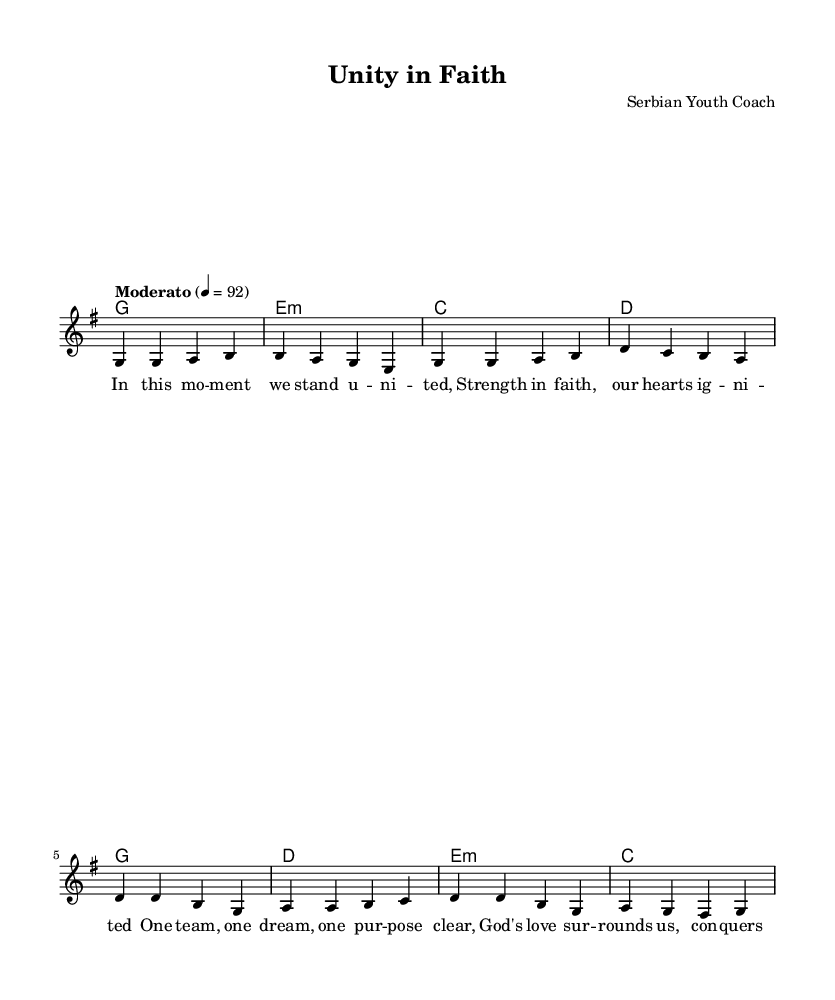What is the key signature of this music? The key signature is G major, which contains one sharp (F#). This is determined by examining the key signature indicated at the beginning of the score.
Answer: G major What is the time signature of this music? The time signature is 4/4, which means there are four beats in each measure. This information is found at the beginning of the sheet music after the key signature.
Answer: 4/4 What is the tempo marking of this music? The tempo marking is "Moderato" at a tempo of 92 beats per minute. This is specified above the staff, indicating how fast the piece should be played.
Answer: Moderato How many measures are in the verse section? There are four measures in the verse section as seen in the music notation where each line of melody and harmonies corresponds to individual measures.
Answer: Four measures What are the main themes expressed in the lyrics? The main themes expressed in the lyrics focus on unity, strength in faith, and overcoming fear through God's love. Analyzing the lyrics reveals a message of collective purpose and trust in a higher power, which is typical in religious music.
Answer: Unity, strength, faith Which chord is used in the first measure? The chord used in the first measure is G major. This can be identified by the chord notation provided above the melody in the score.
Answer: G major What is the lyrical content reflecting the overall message of the song? The lyrical content reflects themes of unity and divine love, emphasizing that faith brings strength and courage. This is inferred by reading the lyrics that describe a united team spirit supported by God's presence.
Answer: Unity in faith 